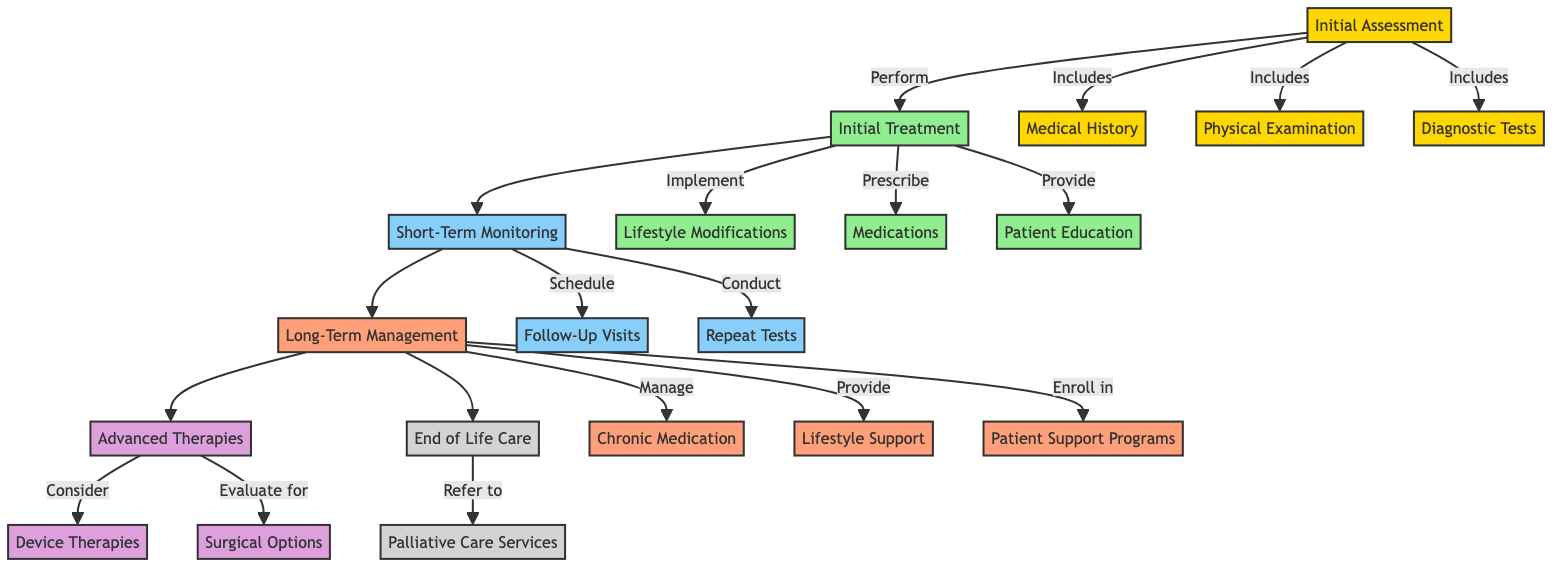What is the first step in the pathway? The diagram shows that the first step in the pathway is the "Initial Assessment." This is the starting point that leads to subsequent processes.
Answer: Initial Assessment How many major components are in the pathway? By counting the main stages represented in the diagram, there are six major components: Initial Assessment, Initial Treatment, Short-Term Monitoring, Long-Term Management, Advanced Therapies, and End of Life Care.
Answer: 6 What comes after the Initial Treatment step? The diagram indicates that after the "Initial Treatment," the next step is "Short-Term Monitoring," which is a direct follow-up to assess the effectiveness of treatment.
Answer: Short-Term Monitoring What are the elements included in the Initial Assessment? The Initial Assessment is broken down into three elements: Medical History, Physical Examination, and Diagnostic Tests, as shown in the diagram.
Answer: Medical History, Physical Examination, Diagnostic Tests Which phase leads to Advanced Therapies? The diagram shows that the "Long-Term Management" phase leads to "Advanced Therapies." This signifies that effective long-term management may require advanced treatment options.
Answer: Long-Term Management What is a key role of Patient Education in the Initial Treatment? The diagram states that "Patient Education" serves to provide instructions on recognizing symptoms and adherence to therapy, which is essential for managing Chronic Heart Failure.
Answer: Instructions on recognizing symptoms, adherence to therapy Which aspect does End of Life Care focus on? The End of Life Care focuses on "Palliative Care Services," which emphasize quality of life and symptom control for patients at the final stage of care.
Answer: Palliative Care Services How are Pacemakers categorized in the pathway? The diagram places Pacemakers under "Device Therapies," which are considered in "Advanced Therapies" for eligible patients, indicating they are a type of advanced intervention.
Answer: Device Therapies What is required for Short-Term Monitoring according to the pathway? According to the pathway, Short-Term Monitoring requires "Follow-Up Visits" and "Repeat Tests" as follow-up measures to assess the patient's response to treatment.
Answer: Follow-Up Visits, Repeat Tests 